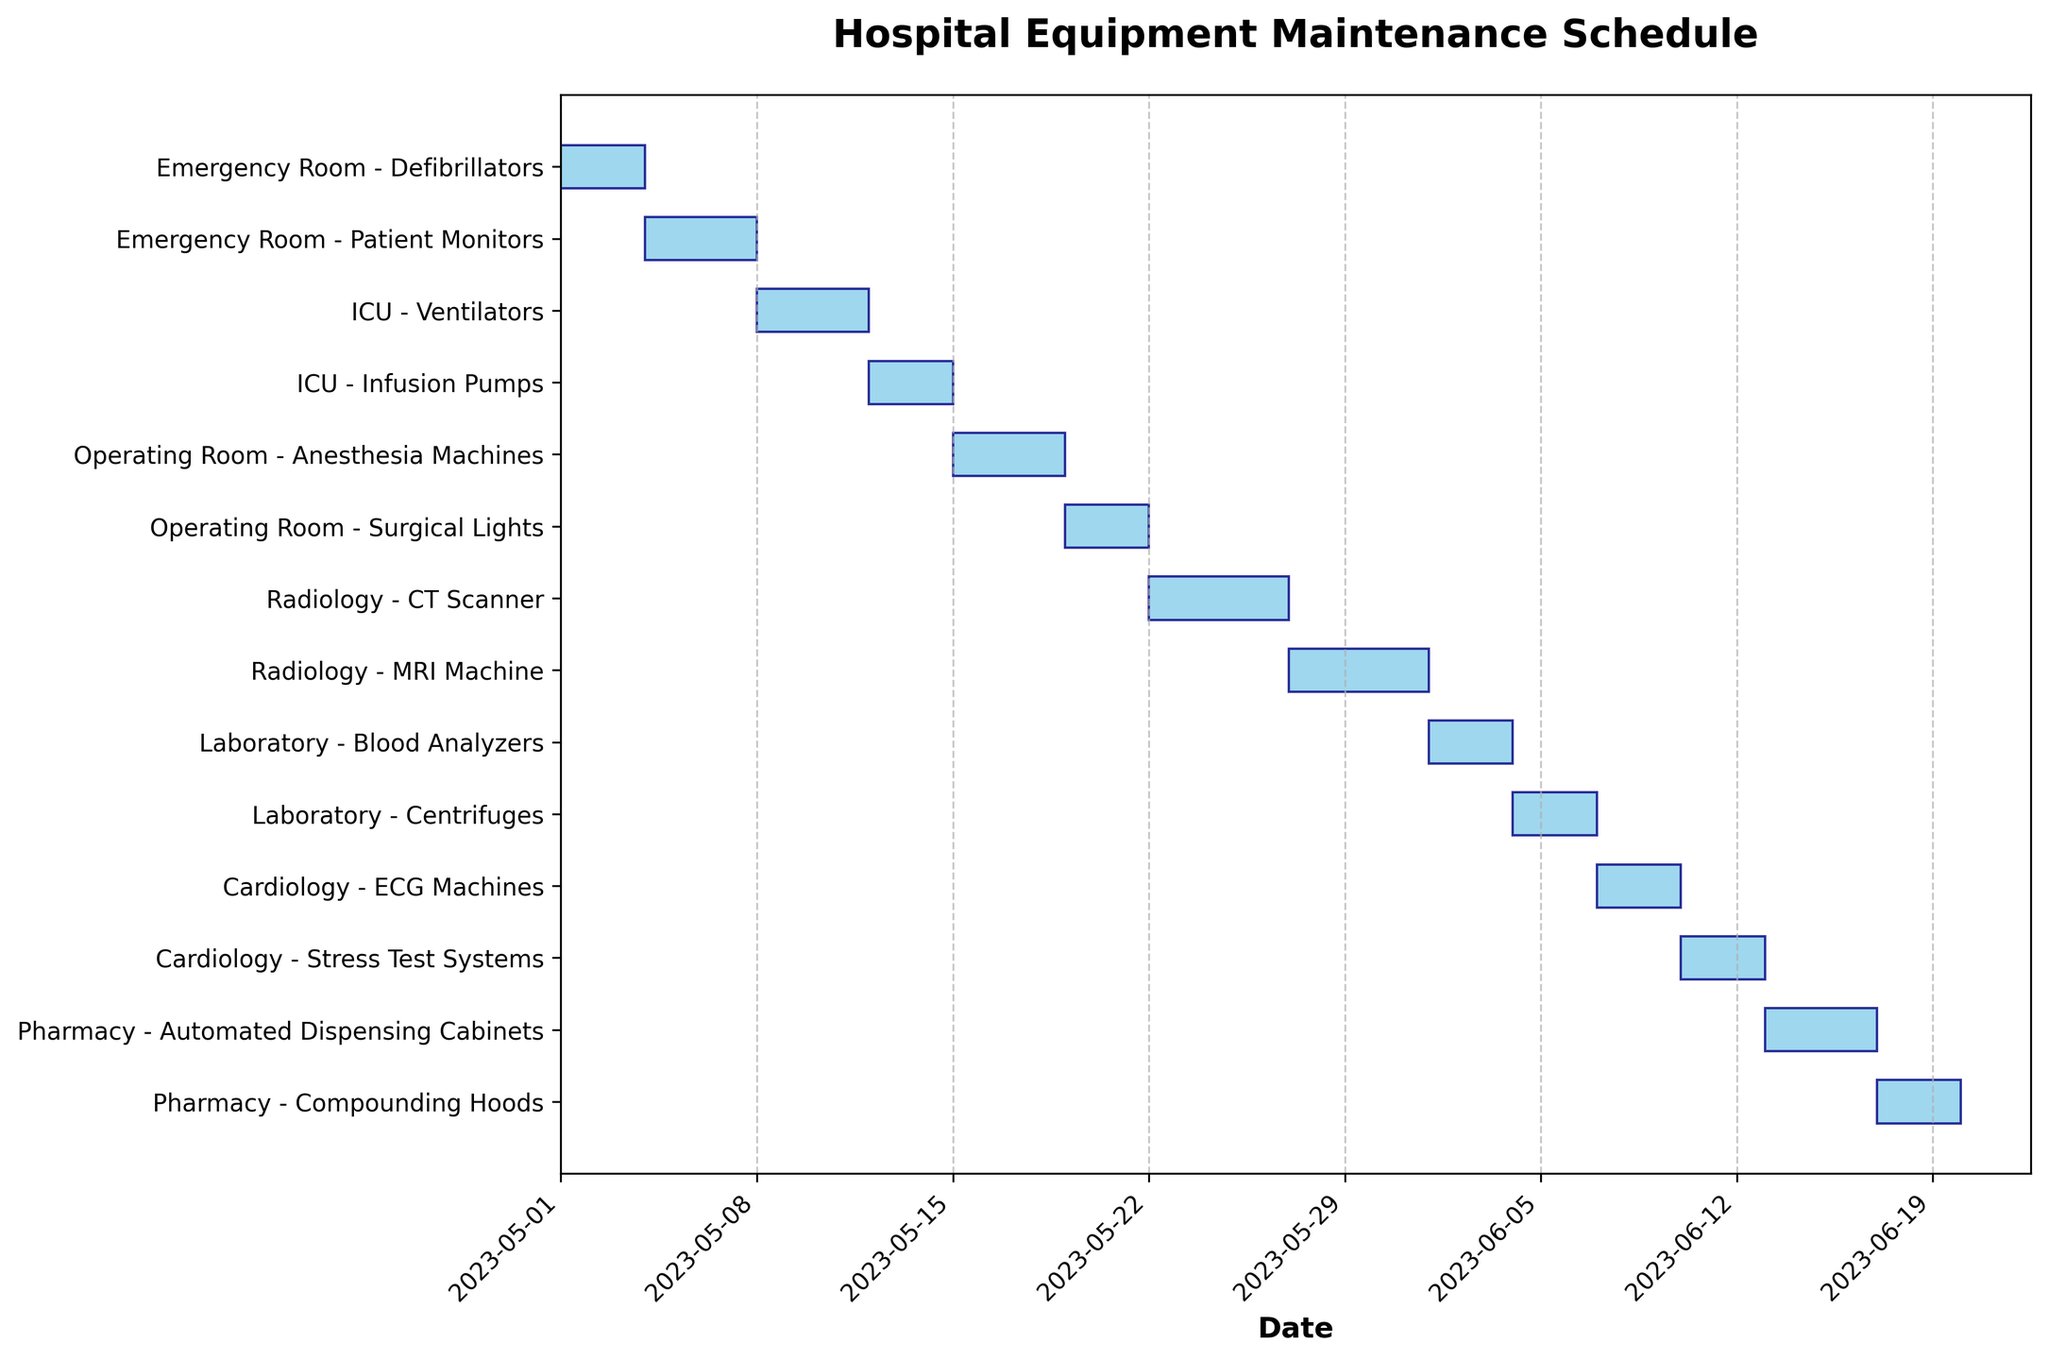What is the title of the Gantt Chart? The title of the chart is displayed at the top center and it reads "Hospital Equipment Maintenance Schedule".
Answer: Hospital Equipment Maintenance Schedule Which department has the first maintenance schedule in May? The Gantt Chart starts at the beginning of May, and the first department listed with a maintenance schedule is the Emergency Room with maintenance on Defibrillators.
Answer: Emergency Room Which equipment in the ICU department has a longer maintenance duration? In the Gantt Chart, the ICU department's Ventilators have a maintenance duration of 4 days (from May 8 to May 11), while Infusion Pumps have a duration of 3 days (from May 12 to May 14), making Ventilators' maintenance longer.
Answer: Ventilators How many days is the total maintenance time for the Laboratory department? The Laboratory department has maintenance for Blood Analyzers for 3 days (June 1 to June 3) and Centrifuges for 3 days (June 4 to June 6). Adding them together results in a total of 3 + 3 = 6 days.
Answer: 6 days What is the start date of the maintenance schedule for the ECG Machines in the Cardiology department? The start date for the maintenance of ECG Machines in the Cardiology department is June 7, as displayed in the Gantt Chart.
Answer: June 7, 2023 Which two departments have maintenance schedules that overlap in May? Analyzing the Gantt Chart, the ICU department's Infusion Pumps (May 12 to May 14) overlap with the Operating Room's Anesthesia Machines (May 15 to May 18) even though they are contiguous, they do not actually overlap. Therefore, no departments overlap within May.
Answer: None What is the longest continuous maintenance period for a single piece of equipment? The longest continuous maintenance period is for the MRI Machine in the Radiology department, spanning from May 27 to May 31, which totals 5 days.
Answer: MRI Machine Which department has the final maintenance schedule in June? The Pharmacy department has the last maintenance schedule in June with the maintenance of Compounding Hoods from June 17 to June 19.
Answer: Pharmacy Compare the maintenance durations of both pieces of equipment in the Radiology department. Which one is longer? The CT Scanner has a maintenance duration from May 22 to May 26 (5 days), and the MRI Machine from May 27 to May 31 (5 days), both durations are equal and each lasts 5 days.
Answer: Both are equal 